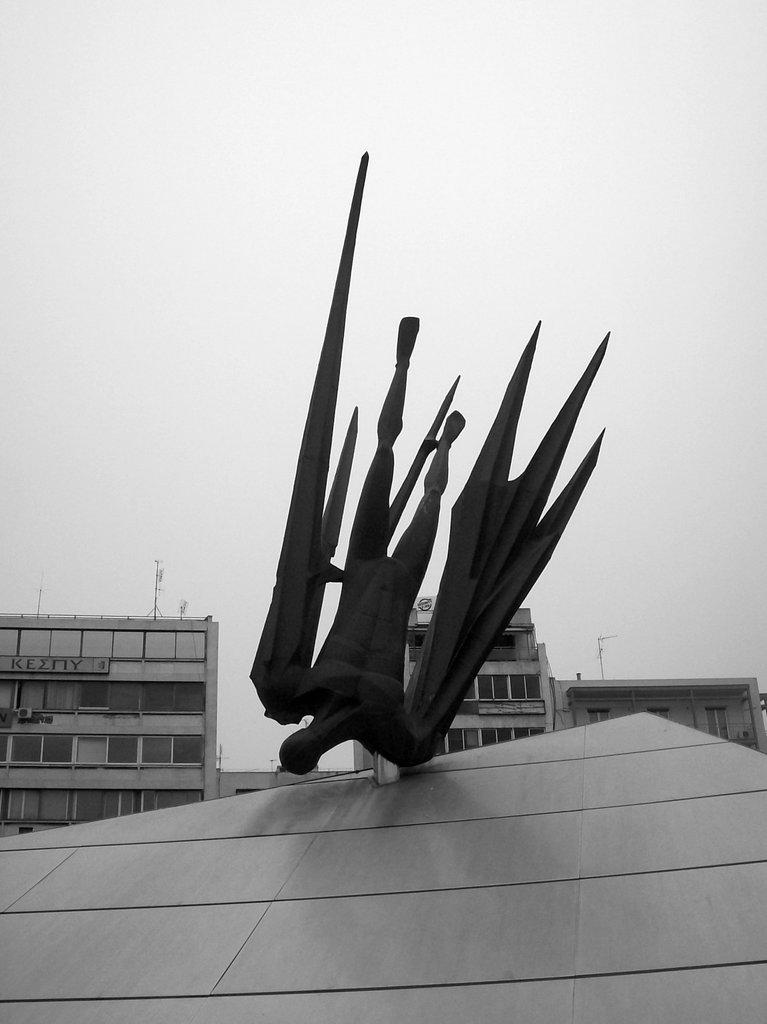What is the color scheme of the image? The image is black and white. What type of structures can be seen in the image? There are buildings in the image. What kind of artwork is present in the image? There is a sculpture on a surface in the image. What can be seen in the distance in the image? The sky is visible in the background of the image. Where is the wrench being used in the image? There is no wrench present in the image. What type of town is depicted in the image? The image does not depict a town; it features buildings and a sculpture. 